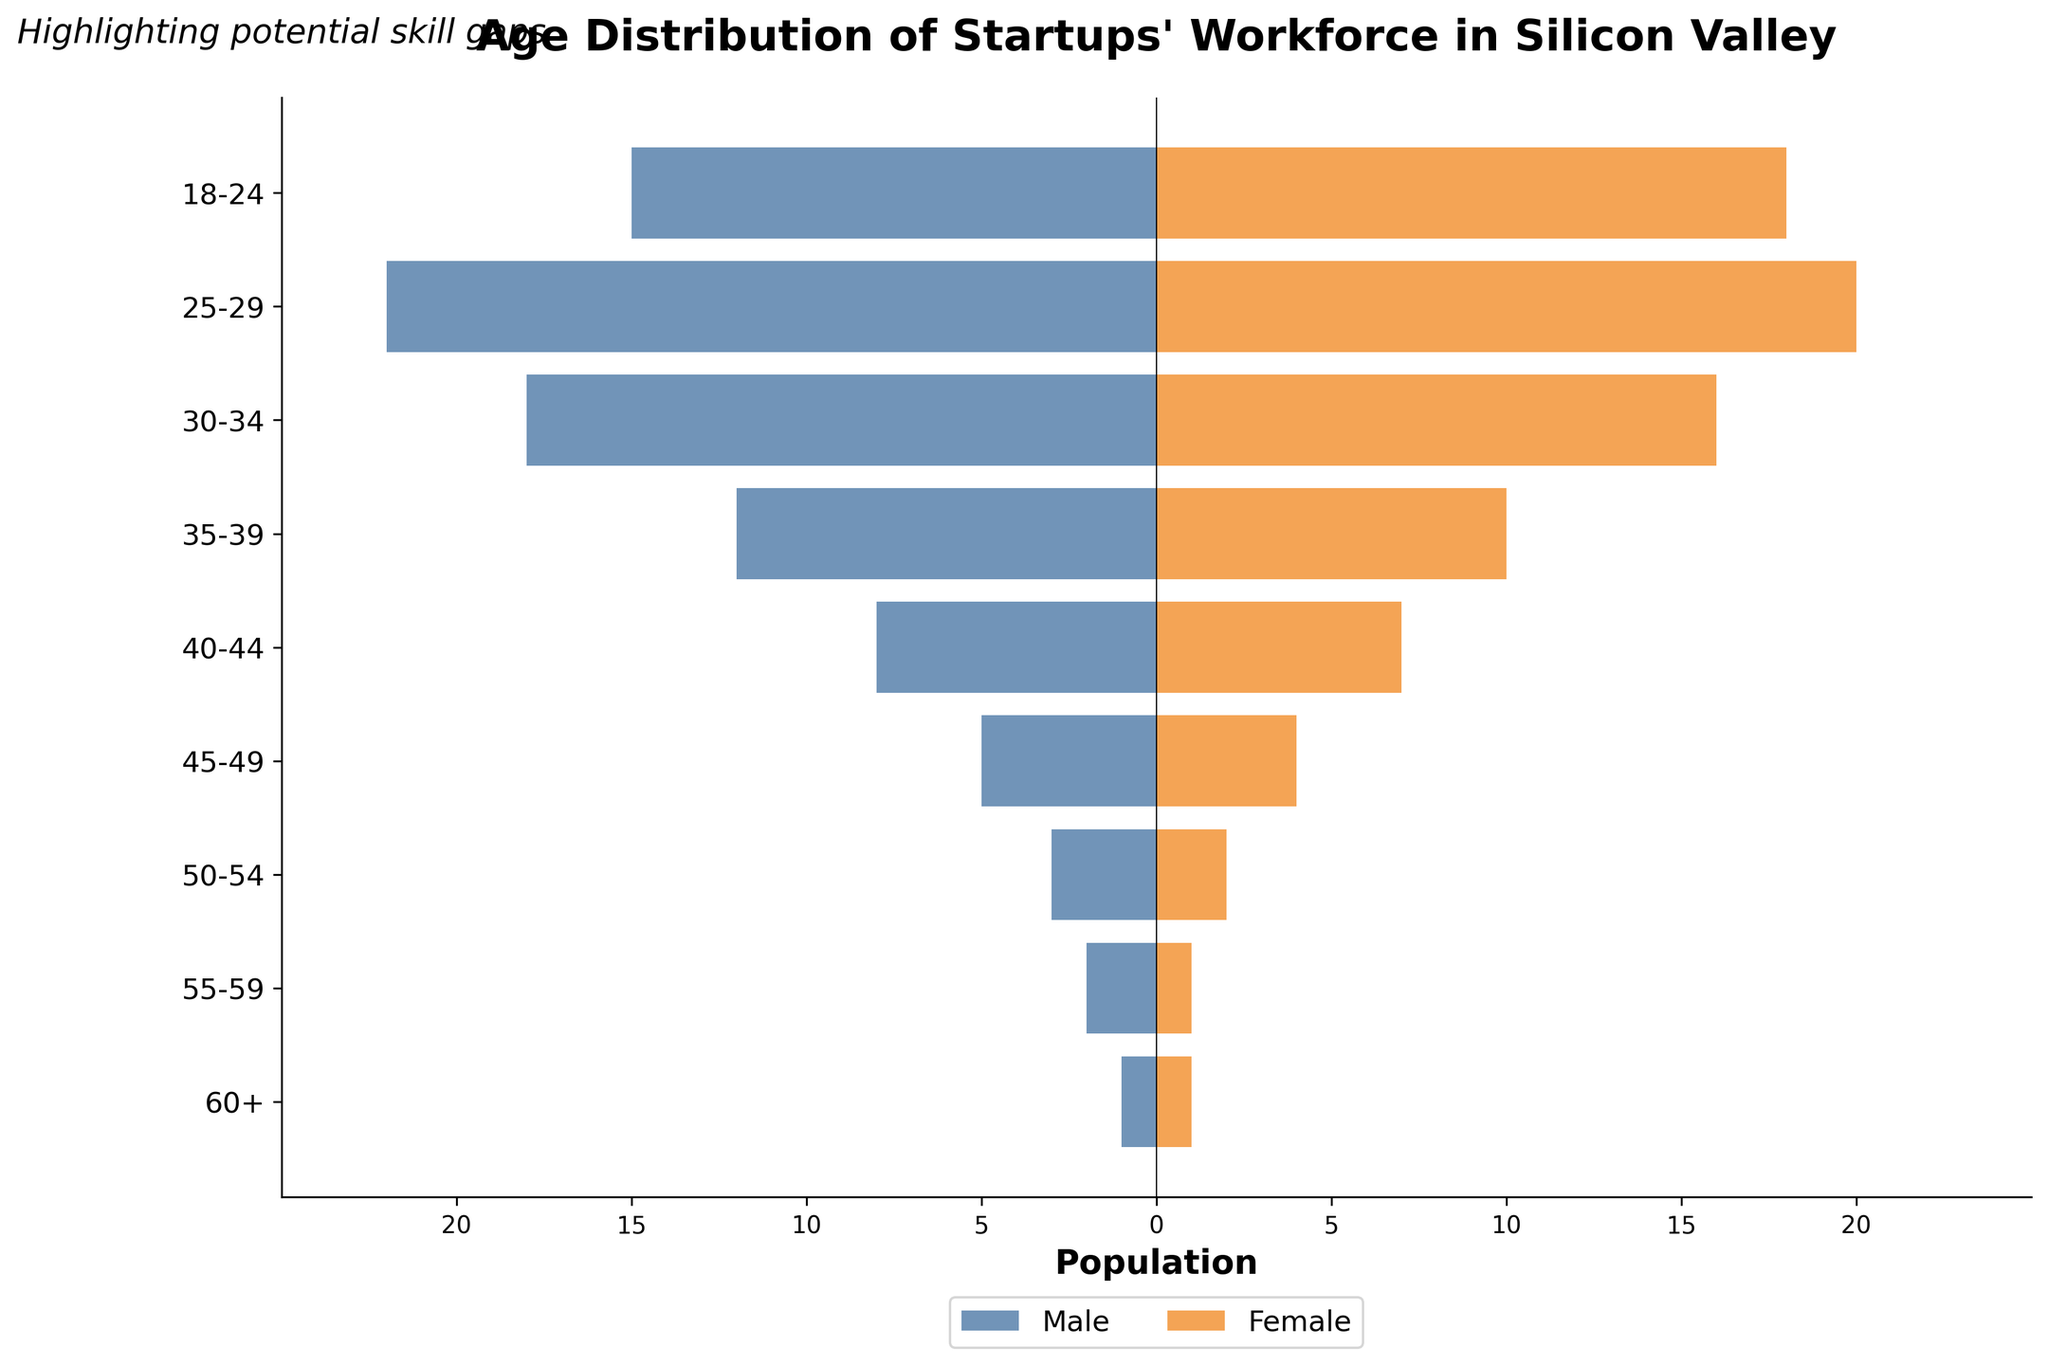What is the title of the plot? The title of the plot is displayed at the top of the figure. It reads "Age Distribution of Startups' Workforce in Silicon Valley".
Answer: Age Distribution of Startups' Workforce in Silicon Valley How many age groups are represented in the plot? The y-axis of the plot lists the age groups, and counting these labels shows there are 9 different age groups.
Answer: 9 Which age group has the highest number of males? Looking at the lengths of the blue bars representing males, the 25-29 age group has the longest bar, indicating the highest number of males.
Answer: 25-29 What is the combined male and female workforce in the 30-34 age group? The bar for males in the 30-34 age group is -18, and for females, it is 16. By taking the absolute value and adding them together: 18 (males) + 16 (females) = 34.
Answer: 34 Are there more males or females in the 18-24 age group? The bar for males in the 18-24 age group is -15 and for females, it is 18. Since 18 is greater than 15, there are more females.
Answer: Females Which gender sees a decrease in workforce after the 25-29 age group? Comparing the length of the bars for males and females between the 25-29 and 30-34 age groups, both see a decrease, but the male workforce decreases more significantly.
Answer: Males What is the total workforce (males and females) aged 60 and above? The bar for males aged 60+ is -1, and for females, it is 1. Therefore, the total workforce in this age group is: 1 (male) + 1 (female) = 2.
Answer: 2 How does the size of the male workforce in the 40-44 age group compare to that in the 50-54 age group? The bar for males in the 40-44 age group is -8 and for the 50-54 age group, it is -3. Since 8 is greater than 3, the male workforce in the 40-44 age group is larger.
Answer: 40-44 What is the male to female ratio in the 45-49 age group? The male bar in the 45-49 age group is -5 and the female bar is 4. Therefore, the male-to-female ratio is 5:4.
Answer: 5:4 Does the graph suggest any potential skill gaps based on age distribution? Analyzing the distribution, there is a much smaller number of employees in the older age groups (50+), which could indicate potential skill gaps as the workforce ages.
Answer: Yes 